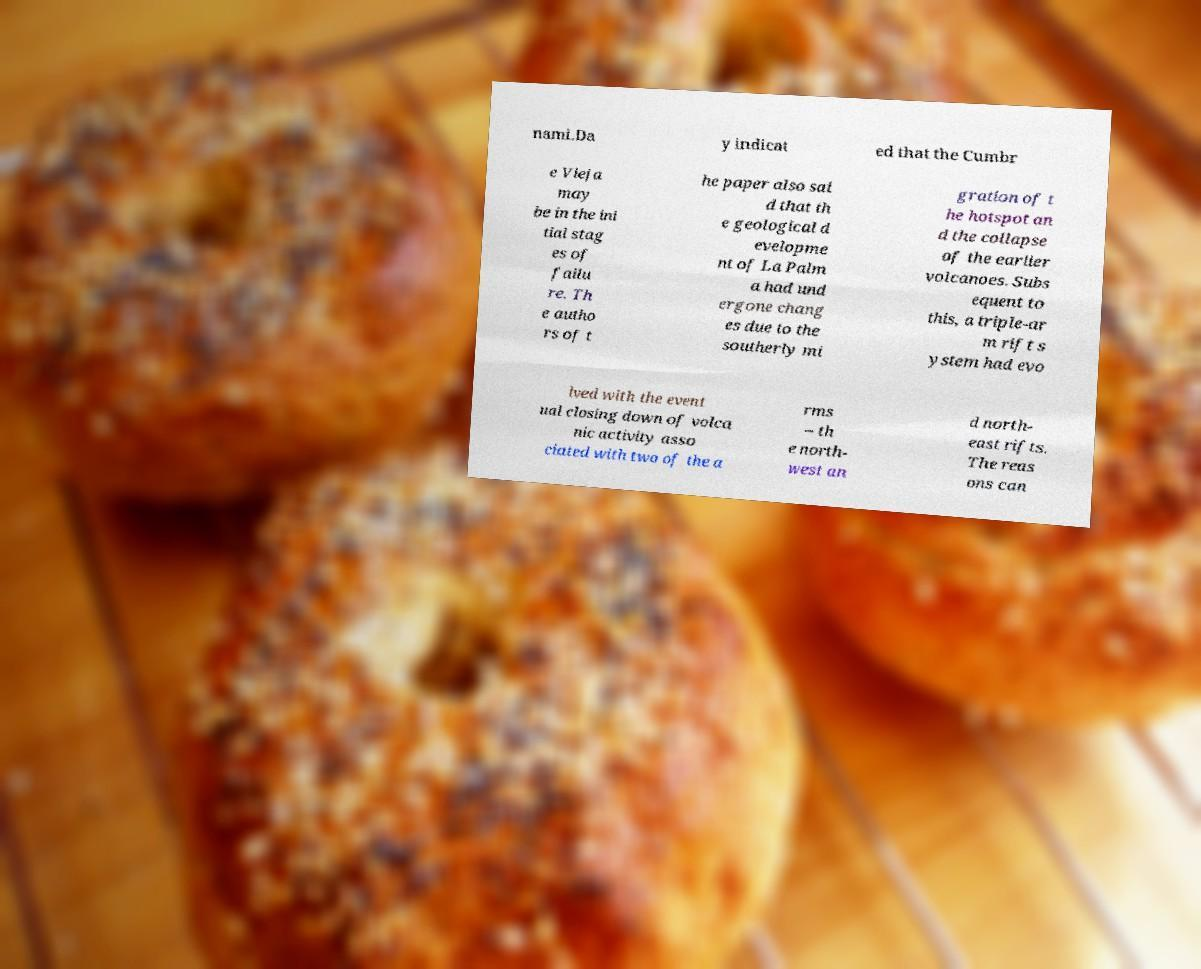Please read and relay the text visible in this image. What does it say? nami.Da y indicat ed that the Cumbr e Vieja may be in the ini tial stag es of failu re. Th e autho rs of t he paper also sai d that th e geological d evelopme nt of La Palm a had und ergone chang es due to the southerly mi gration of t he hotspot an d the collapse of the earlier volcanoes. Subs equent to this, a triple-ar m rift s ystem had evo lved with the event ual closing down of volca nic activity asso ciated with two of the a rms – th e north- west an d north- east rifts. The reas ons can 